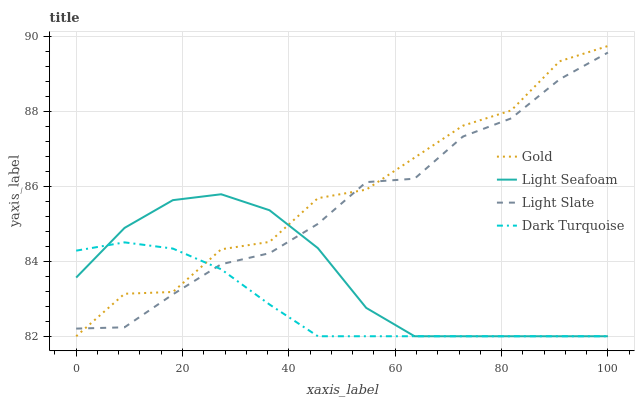Does Dark Turquoise have the minimum area under the curve?
Answer yes or no. Yes. Does Gold have the maximum area under the curve?
Answer yes or no. Yes. Does Light Seafoam have the minimum area under the curve?
Answer yes or no. No. Does Light Seafoam have the maximum area under the curve?
Answer yes or no. No. Is Dark Turquoise the smoothest?
Answer yes or no. Yes. Is Gold the roughest?
Answer yes or no. Yes. Is Light Seafoam the smoothest?
Answer yes or no. No. Is Light Seafoam the roughest?
Answer yes or no. No. Does Dark Turquoise have the lowest value?
Answer yes or no. Yes. Does Gold have the highest value?
Answer yes or no. Yes. Does Light Seafoam have the highest value?
Answer yes or no. No. Does Light Slate intersect Gold?
Answer yes or no. Yes. Is Light Slate less than Gold?
Answer yes or no. No. Is Light Slate greater than Gold?
Answer yes or no. No. 